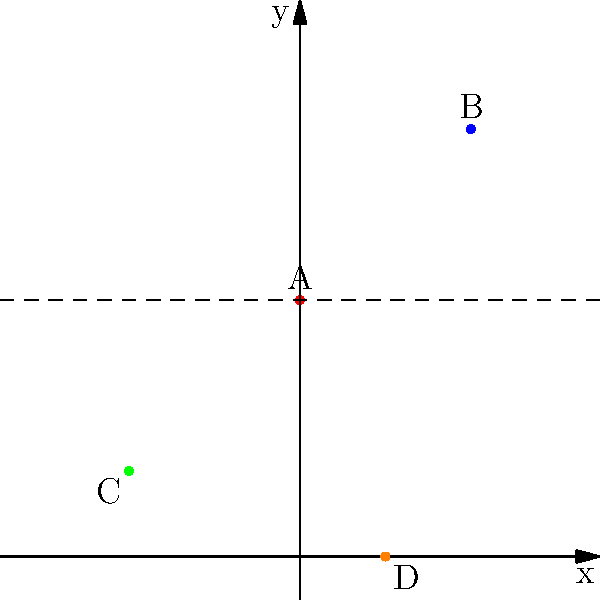In a badminton doubles match in Portugal, the positions of four players are mapped on a coordinate grid. Player A is at (0,6), Player B is at (4,10), Player C is at (-4,2), and Player D is at (2,0). What is the total distance between the two players farthest apart from each other? To solve this problem, we need to follow these steps:

1. Identify all possible pairs of players:
   AB, AC, AD, BC, BD, CD

2. Calculate the distance between each pair using the distance formula:
   $d = \sqrt{(x_2-x_1)^2 + (y_2-y_1)^2}$

3. For AB: $d_{AB} = \sqrt{(4-0)^2 + (10-6)^2} = \sqrt{16 + 16} = \sqrt{32} = 4\sqrt{2}$

4. For AC: $d_{AC} = \sqrt{(-4-0)^2 + (2-6)^2} = \sqrt{16 + 16} = \sqrt{32} = 4\sqrt{2}$

5. For AD: $d_{AD} = \sqrt{(2-0)^2 + (0-6)^2} = \sqrt{4 + 36} = \sqrt{40} = 2\sqrt{10}$

6. For BC: $d_{BC} = \sqrt{(-4-4)^2 + (2-10)^2} = \sqrt{64 + 64} = \sqrt{128} = 8\sqrt{2}$

7. For BD: $d_{BD} = \sqrt{(2-4)^2 + (0-10)^2} = \sqrt{4 + 100} = \sqrt{104} = 2\sqrt{26}$

8. For CD: $d_{CD} = \sqrt{(2-(-4))^2 + (0-2)^2} = \sqrt{36 + 4} = \sqrt{40} = 2\sqrt{10}$

9. The largest distance is between players B and C: $8\sqrt{2}$

10. Convert $8\sqrt{2}$ to a decimal: $8\sqrt{2} \approx 11.31$ units
Answer: 11.31 units 